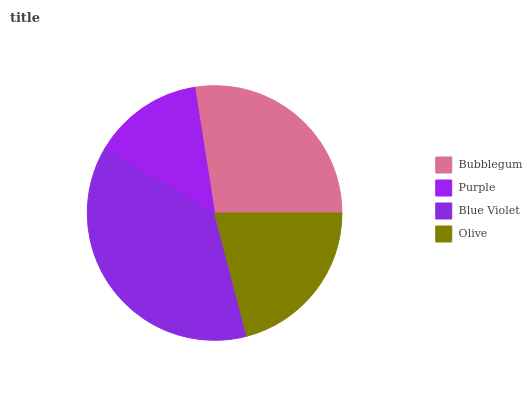Is Purple the minimum?
Answer yes or no. Yes. Is Blue Violet the maximum?
Answer yes or no. Yes. Is Blue Violet the minimum?
Answer yes or no. No. Is Purple the maximum?
Answer yes or no. No. Is Blue Violet greater than Purple?
Answer yes or no. Yes. Is Purple less than Blue Violet?
Answer yes or no. Yes. Is Purple greater than Blue Violet?
Answer yes or no. No. Is Blue Violet less than Purple?
Answer yes or no. No. Is Bubblegum the high median?
Answer yes or no. Yes. Is Olive the low median?
Answer yes or no. Yes. Is Olive the high median?
Answer yes or no. No. Is Bubblegum the low median?
Answer yes or no. No. 